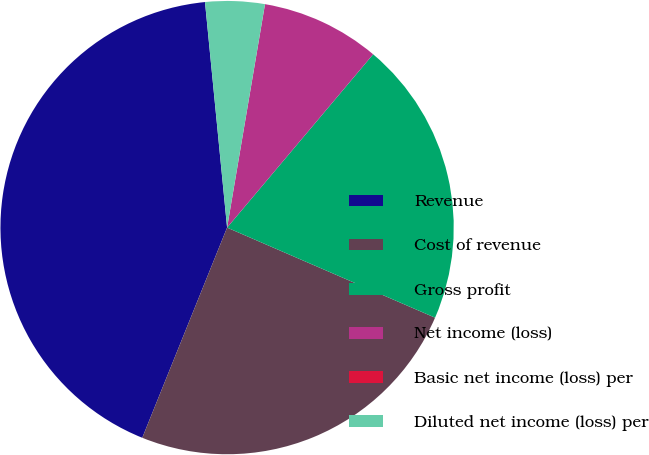Convert chart. <chart><loc_0><loc_0><loc_500><loc_500><pie_chart><fcel>Revenue<fcel>Cost of revenue<fcel>Gross profit<fcel>Net income (loss)<fcel>Basic net income (loss) per<fcel>Diluted net income (loss) per<nl><fcel>42.34%<fcel>24.6%<fcel>20.36%<fcel>8.47%<fcel>0.0%<fcel>4.23%<nl></chart> 